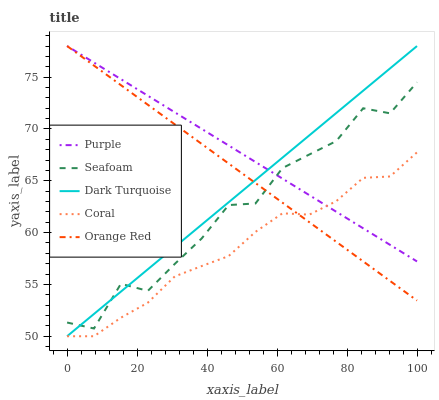Does Coral have the minimum area under the curve?
Answer yes or no. Yes. Does Purple have the maximum area under the curve?
Answer yes or no. Yes. Does Dark Turquoise have the minimum area under the curve?
Answer yes or no. No. Does Dark Turquoise have the maximum area under the curve?
Answer yes or no. No. Is Dark Turquoise the smoothest?
Answer yes or no. Yes. Is Seafoam the roughest?
Answer yes or no. Yes. Is Coral the smoothest?
Answer yes or no. No. Is Coral the roughest?
Answer yes or no. No. Does Dark Turquoise have the lowest value?
Answer yes or no. Yes. Does Seafoam have the lowest value?
Answer yes or no. No. Does Orange Red have the highest value?
Answer yes or no. Yes. Does Dark Turquoise have the highest value?
Answer yes or no. No. Is Coral less than Seafoam?
Answer yes or no. Yes. Is Seafoam greater than Coral?
Answer yes or no. Yes. Does Coral intersect Purple?
Answer yes or no. Yes. Is Coral less than Purple?
Answer yes or no. No. Is Coral greater than Purple?
Answer yes or no. No. Does Coral intersect Seafoam?
Answer yes or no. No. 